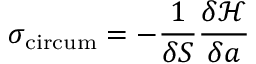Convert formula to latex. <formula><loc_0><loc_0><loc_500><loc_500>\sigma _ { c i r c u m } = - \frac { 1 } { \delta S } \frac { \delta \mathcal { H } } { \delta a }</formula> 